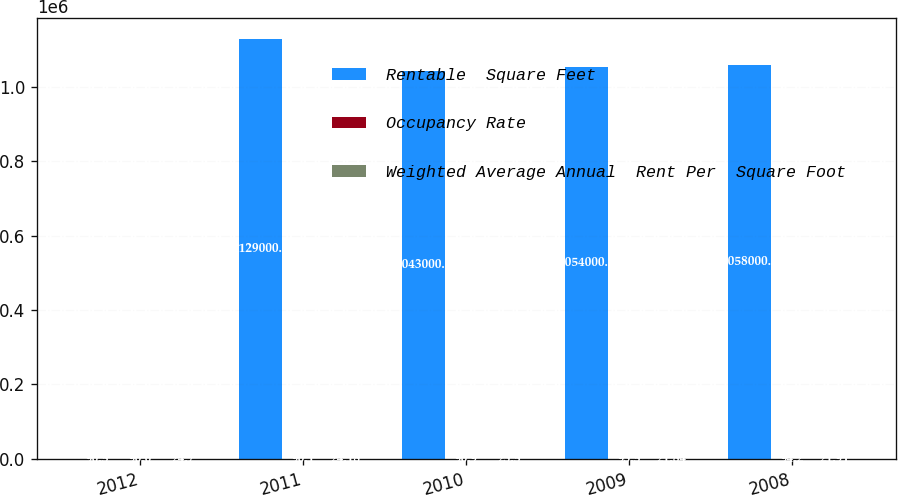Convert chart to OTSL. <chart><loc_0><loc_0><loc_500><loc_500><stacked_bar_chart><ecel><fcel>2012<fcel>2011<fcel>2010<fcel>2009<fcel>2008<nl><fcel>Rentable  Square Feet<fcel>90.5<fcel>1.129e+06<fcel>1.043e+06<fcel>1.054e+06<fcel>1.058e+06<nl><fcel>Occupancy Rate<fcel>90<fcel>90.1<fcel>90.9<fcel>93.5<fcel>94.2<nl><fcel>Weighted Average Annual  Rent Per  Square Foot<fcel>24.7<fcel>24.18<fcel>23.5<fcel>21.84<fcel>21.91<nl></chart> 